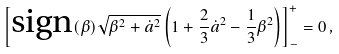Convert formula to latex. <formula><loc_0><loc_0><loc_500><loc_500>\left [ \text {sign} ( \beta ) \sqrt { \beta ^ { 2 } + \dot { a } ^ { 2 } } \left ( 1 + \frac { 2 } { 3 } \dot { a } ^ { 2 } - \frac { 1 } { 3 } \beta ^ { 2 } \right ) \right ] ^ { + } _ { - } = 0 \, ,</formula> 